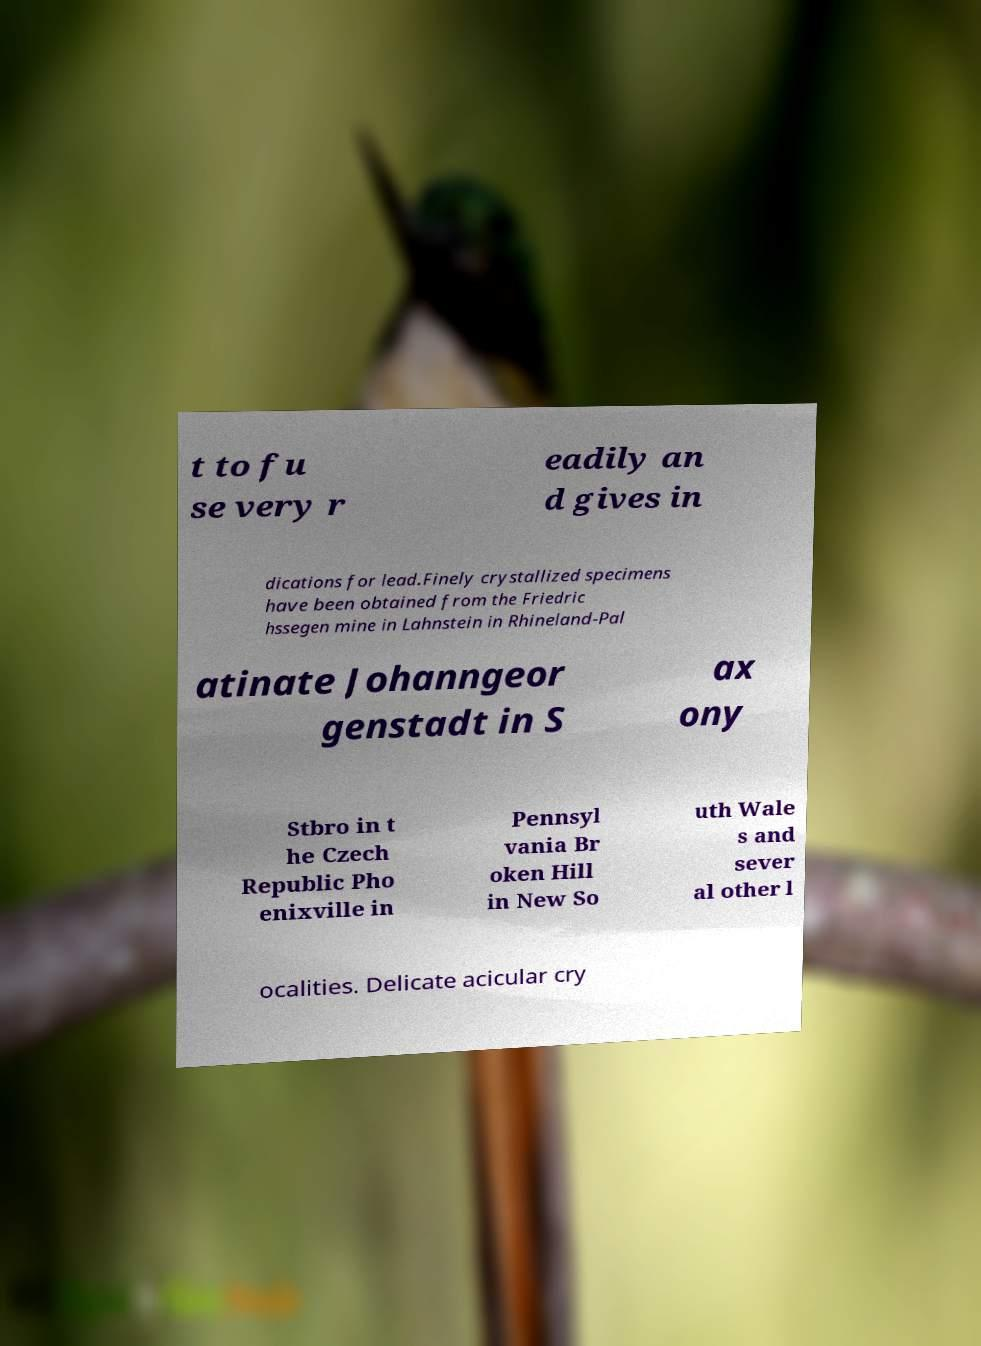For documentation purposes, I need the text within this image transcribed. Could you provide that? t to fu se very r eadily an d gives in dications for lead.Finely crystallized specimens have been obtained from the Friedric hssegen mine in Lahnstein in Rhineland-Pal atinate Johanngeor genstadt in S ax ony Stbro in t he Czech Republic Pho enixville in Pennsyl vania Br oken Hill in New So uth Wale s and sever al other l ocalities. Delicate acicular cry 